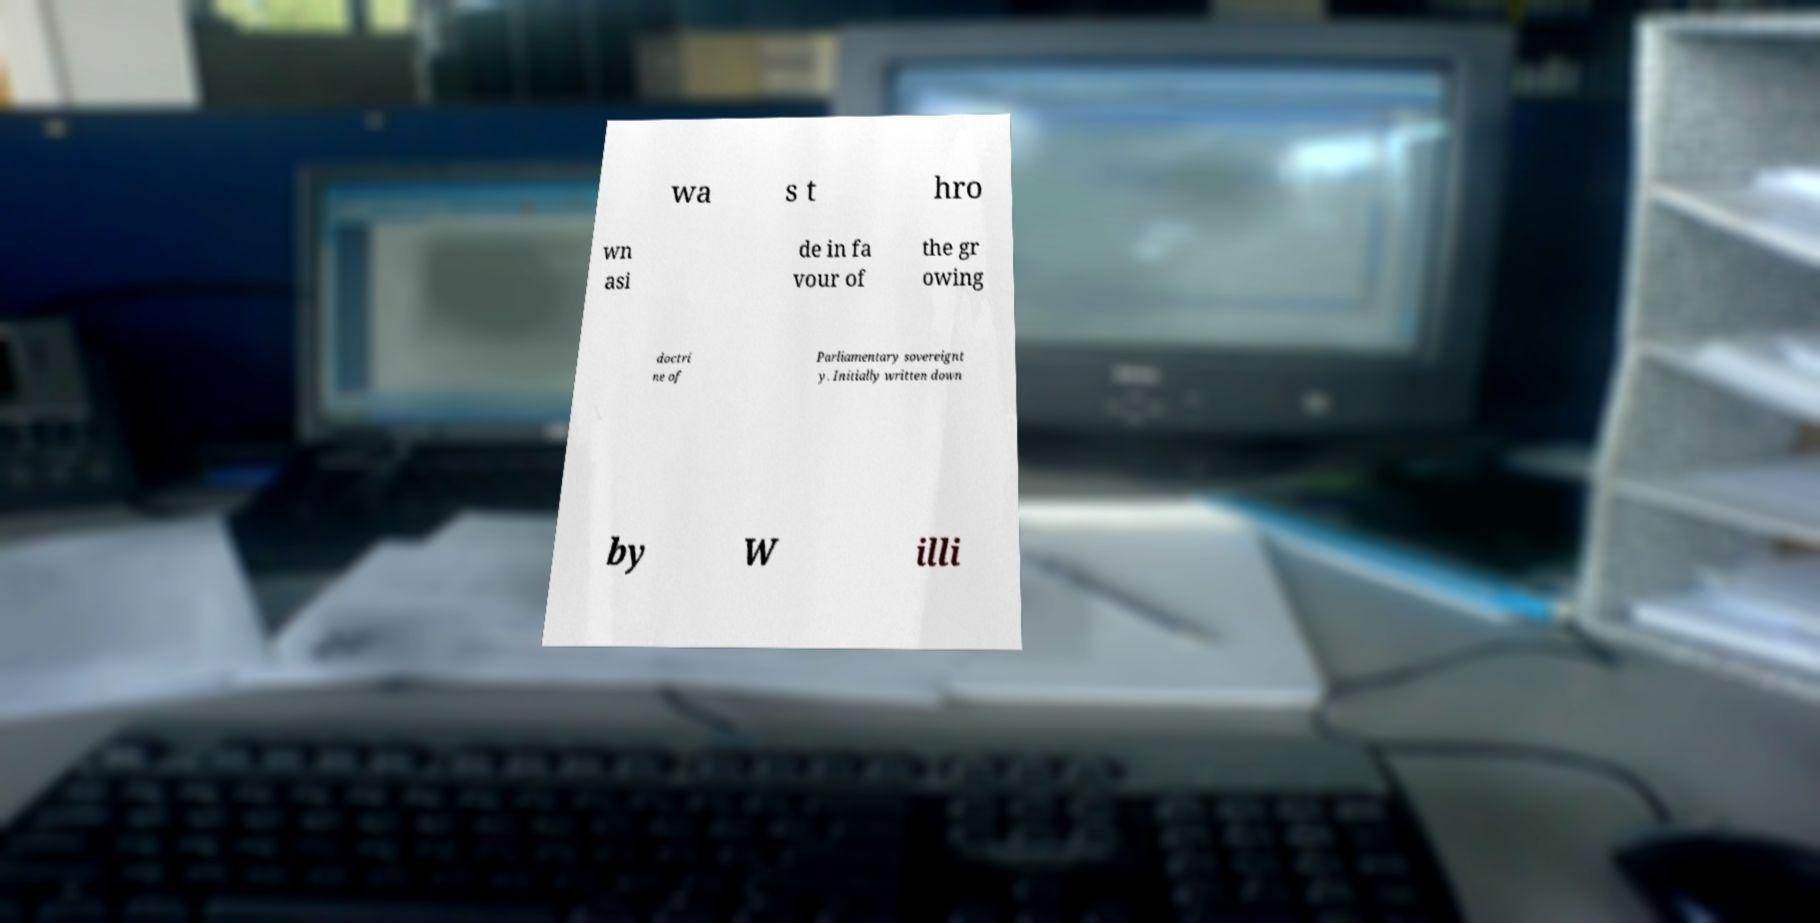What messages or text are displayed in this image? I need them in a readable, typed format. wa s t hro wn asi de in fa vour of the gr owing doctri ne of Parliamentary sovereignt y. Initially written down by W illi 